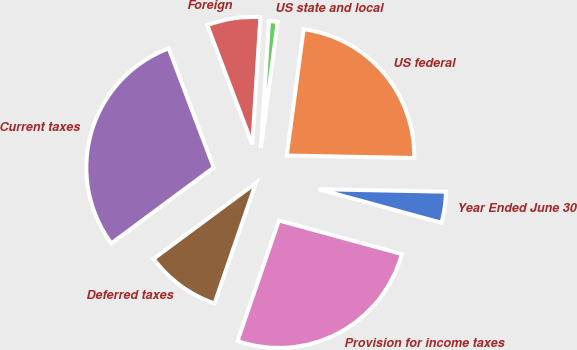Convert chart to OTSL. <chart><loc_0><loc_0><loc_500><loc_500><pie_chart><fcel>Year Ended June 30<fcel>US federal<fcel>US state and local<fcel>Foreign<fcel>Current taxes<fcel>Deferred taxes<fcel>Provision for income taxes<nl><fcel>3.93%<fcel>23.2%<fcel>1.1%<fcel>6.76%<fcel>29.4%<fcel>9.59%<fcel>26.03%<nl></chart> 